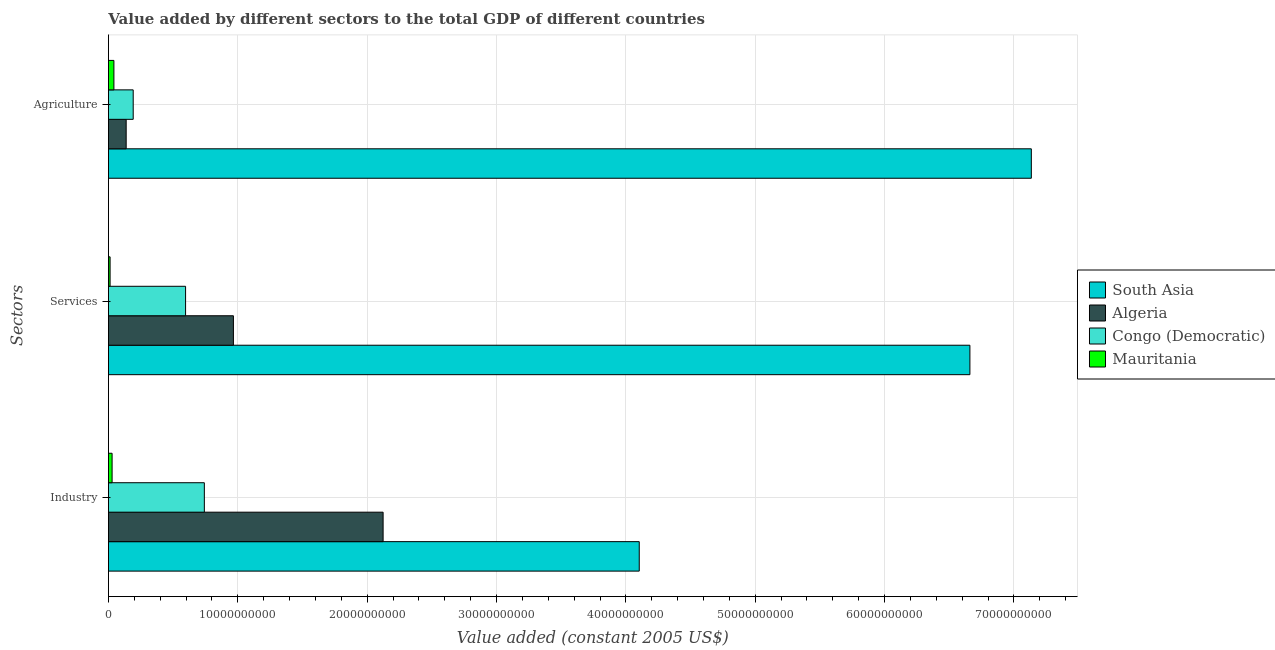How many groups of bars are there?
Make the answer very short. 3. Are the number of bars per tick equal to the number of legend labels?
Your answer should be very brief. Yes. How many bars are there on the 3rd tick from the top?
Keep it short and to the point. 4. What is the label of the 2nd group of bars from the top?
Offer a very short reply. Services. What is the value added by agricultural sector in Mauritania?
Make the answer very short. 4.24e+08. Across all countries, what is the maximum value added by services?
Your answer should be very brief. 6.66e+1. Across all countries, what is the minimum value added by industrial sector?
Offer a very short reply. 2.83e+08. In which country was the value added by agricultural sector maximum?
Your response must be concise. South Asia. In which country was the value added by industrial sector minimum?
Your response must be concise. Mauritania. What is the total value added by agricultural sector in the graph?
Give a very brief answer. 7.51e+1. What is the difference between the value added by industrial sector in Algeria and that in Congo (Democratic)?
Make the answer very short. 1.38e+1. What is the difference between the value added by industrial sector in Algeria and the value added by agricultural sector in South Asia?
Provide a succinct answer. -5.01e+1. What is the average value added by agricultural sector per country?
Provide a short and direct response. 1.88e+1. What is the difference between the value added by agricultural sector and value added by industrial sector in Mauritania?
Give a very brief answer. 1.40e+08. What is the ratio of the value added by services in Congo (Democratic) to that in Mauritania?
Your response must be concise. 46.56. Is the difference between the value added by industrial sector in Algeria and South Asia greater than the difference between the value added by services in Algeria and South Asia?
Keep it short and to the point. Yes. What is the difference between the highest and the second highest value added by industrial sector?
Offer a terse response. 1.98e+1. What is the difference between the highest and the lowest value added by agricultural sector?
Make the answer very short. 7.09e+1. Is the sum of the value added by services in Congo (Democratic) and South Asia greater than the maximum value added by agricultural sector across all countries?
Offer a very short reply. Yes. What does the 1st bar from the top in Services represents?
Offer a very short reply. Mauritania. What does the 2nd bar from the bottom in Industry represents?
Your response must be concise. Algeria. Is it the case that in every country, the sum of the value added by industrial sector and value added by services is greater than the value added by agricultural sector?
Provide a succinct answer. No. How many bars are there?
Offer a terse response. 12. How many countries are there in the graph?
Your answer should be very brief. 4. What is the difference between two consecutive major ticks on the X-axis?
Your answer should be compact. 1.00e+1. Does the graph contain grids?
Offer a terse response. Yes. How many legend labels are there?
Keep it short and to the point. 4. How are the legend labels stacked?
Offer a very short reply. Vertical. What is the title of the graph?
Your answer should be very brief. Value added by different sectors to the total GDP of different countries. Does "Guyana" appear as one of the legend labels in the graph?
Offer a very short reply. No. What is the label or title of the X-axis?
Your answer should be compact. Value added (constant 2005 US$). What is the label or title of the Y-axis?
Provide a succinct answer. Sectors. What is the Value added (constant 2005 US$) of South Asia in Industry?
Your answer should be compact. 4.10e+1. What is the Value added (constant 2005 US$) in Algeria in Industry?
Your answer should be very brief. 2.12e+1. What is the Value added (constant 2005 US$) in Congo (Democratic) in Industry?
Ensure brevity in your answer.  7.41e+09. What is the Value added (constant 2005 US$) of Mauritania in Industry?
Provide a short and direct response. 2.83e+08. What is the Value added (constant 2005 US$) of South Asia in Services?
Make the answer very short. 6.66e+1. What is the Value added (constant 2005 US$) in Algeria in Services?
Give a very brief answer. 9.66e+09. What is the Value added (constant 2005 US$) in Congo (Democratic) in Services?
Your answer should be very brief. 5.96e+09. What is the Value added (constant 2005 US$) of Mauritania in Services?
Ensure brevity in your answer.  1.28e+08. What is the Value added (constant 2005 US$) in South Asia in Agriculture?
Provide a short and direct response. 7.13e+1. What is the Value added (constant 2005 US$) of Algeria in Agriculture?
Provide a short and direct response. 1.37e+09. What is the Value added (constant 2005 US$) in Congo (Democratic) in Agriculture?
Your answer should be compact. 1.91e+09. What is the Value added (constant 2005 US$) of Mauritania in Agriculture?
Give a very brief answer. 4.24e+08. Across all Sectors, what is the maximum Value added (constant 2005 US$) of South Asia?
Provide a short and direct response. 7.13e+1. Across all Sectors, what is the maximum Value added (constant 2005 US$) of Algeria?
Provide a succinct answer. 2.12e+1. Across all Sectors, what is the maximum Value added (constant 2005 US$) in Congo (Democratic)?
Your answer should be very brief. 7.41e+09. Across all Sectors, what is the maximum Value added (constant 2005 US$) of Mauritania?
Give a very brief answer. 4.24e+08. Across all Sectors, what is the minimum Value added (constant 2005 US$) in South Asia?
Your answer should be compact. 4.10e+1. Across all Sectors, what is the minimum Value added (constant 2005 US$) in Algeria?
Give a very brief answer. 1.37e+09. Across all Sectors, what is the minimum Value added (constant 2005 US$) in Congo (Democratic)?
Your answer should be compact. 1.91e+09. Across all Sectors, what is the minimum Value added (constant 2005 US$) of Mauritania?
Provide a succinct answer. 1.28e+08. What is the total Value added (constant 2005 US$) of South Asia in the graph?
Ensure brevity in your answer.  1.79e+11. What is the total Value added (constant 2005 US$) of Algeria in the graph?
Give a very brief answer. 3.23e+1. What is the total Value added (constant 2005 US$) of Congo (Democratic) in the graph?
Provide a succinct answer. 1.53e+1. What is the total Value added (constant 2005 US$) of Mauritania in the graph?
Make the answer very short. 8.35e+08. What is the difference between the Value added (constant 2005 US$) in South Asia in Industry and that in Services?
Offer a very short reply. -2.56e+1. What is the difference between the Value added (constant 2005 US$) of Algeria in Industry and that in Services?
Your response must be concise. 1.16e+1. What is the difference between the Value added (constant 2005 US$) of Congo (Democratic) in Industry and that in Services?
Give a very brief answer. 1.45e+09. What is the difference between the Value added (constant 2005 US$) in Mauritania in Industry and that in Services?
Make the answer very short. 1.55e+08. What is the difference between the Value added (constant 2005 US$) of South Asia in Industry and that in Agriculture?
Keep it short and to the point. -3.03e+1. What is the difference between the Value added (constant 2005 US$) of Algeria in Industry and that in Agriculture?
Offer a terse response. 1.99e+1. What is the difference between the Value added (constant 2005 US$) in Congo (Democratic) in Industry and that in Agriculture?
Ensure brevity in your answer.  5.50e+09. What is the difference between the Value added (constant 2005 US$) in Mauritania in Industry and that in Agriculture?
Provide a short and direct response. -1.40e+08. What is the difference between the Value added (constant 2005 US$) in South Asia in Services and that in Agriculture?
Provide a short and direct response. -4.75e+09. What is the difference between the Value added (constant 2005 US$) of Algeria in Services and that in Agriculture?
Your answer should be compact. 8.29e+09. What is the difference between the Value added (constant 2005 US$) in Congo (Democratic) in Services and that in Agriculture?
Provide a succinct answer. 4.05e+09. What is the difference between the Value added (constant 2005 US$) of Mauritania in Services and that in Agriculture?
Provide a succinct answer. -2.95e+08. What is the difference between the Value added (constant 2005 US$) of South Asia in Industry and the Value added (constant 2005 US$) of Algeria in Services?
Keep it short and to the point. 3.14e+1. What is the difference between the Value added (constant 2005 US$) of South Asia in Industry and the Value added (constant 2005 US$) of Congo (Democratic) in Services?
Ensure brevity in your answer.  3.51e+1. What is the difference between the Value added (constant 2005 US$) of South Asia in Industry and the Value added (constant 2005 US$) of Mauritania in Services?
Ensure brevity in your answer.  4.09e+1. What is the difference between the Value added (constant 2005 US$) in Algeria in Industry and the Value added (constant 2005 US$) in Congo (Democratic) in Services?
Your response must be concise. 1.53e+1. What is the difference between the Value added (constant 2005 US$) in Algeria in Industry and the Value added (constant 2005 US$) in Mauritania in Services?
Provide a succinct answer. 2.11e+1. What is the difference between the Value added (constant 2005 US$) in Congo (Democratic) in Industry and the Value added (constant 2005 US$) in Mauritania in Services?
Make the answer very short. 7.29e+09. What is the difference between the Value added (constant 2005 US$) in South Asia in Industry and the Value added (constant 2005 US$) in Algeria in Agriculture?
Provide a succinct answer. 3.97e+1. What is the difference between the Value added (constant 2005 US$) of South Asia in Industry and the Value added (constant 2005 US$) of Congo (Democratic) in Agriculture?
Ensure brevity in your answer.  3.91e+1. What is the difference between the Value added (constant 2005 US$) of South Asia in Industry and the Value added (constant 2005 US$) of Mauritania in Agriculture?
Your response must be concise. 4.06e+1. What is the difference between the Value added (constant 2005 US$) of Algeria in Industry and the Value added (constant 2005 US$) of Congo (Democratic) in Agriculture?
Provide a short and direct response. 1.93e+1. What is the difference between the Value added (constant 2005 US$) in Algeria in Industry and the Value added (constant 2005 US$) in Mauritania in Agriculture?
Your response must be concise. 2.08e+1. What is the difference between the Value added (constant 2005 US$) of Congo (Democratic) in Industry and the Value added (constant 2005 US$) of Mauritania in Agriculture?
Provide a short and direct response. 6.99e+09. What is the difference between the Value added (constant 2005 US$) in South Asia in Services and the Value added (constant 2005 US$) in Algeria in Agriculture?
Your answer should be very brief. 6.52e+1. What is the difference between the Value added (constant 2005 US$) in South Asia in Services and the Value added (constant 2005 US$) in Congo (Democratic) in Agriculture?
Provide a short and direct response. 6.47e+1. What is the difference between the Value added (constant 2005 US$) in South Asia in Services and the Value added (constant 2005 US$) in Mauritania in Agriculture?
Give a very brief answer. 6.62e+1. What is the difference between the Value added (constant 2005 US$) of Algeria in Services and the Value added (constant 2005 US$) of Congo (Democratic) in Agriculture?
Your answer should be very brief. 7.75e+09. What is the difference between the Value added (constant 2005 US$) of Algeria in Services and the Value added (constant 2005 US$) of Mauritania in Agriculture?
Your answer should be very brief. 9.24e+09. What is the difference between the Value added (constant 2005 US$) in Congo (Democratic) in Services and the Value added (constant 2005 US$) in Mauritania in Agriculture?
Offer a terse response. 5.54e+09. What is the average Value added (constant 2005 US$) of South Asia per Sectors?
Your response must be concise. 5.97e+1. What is the average Value added (constant 2005 US$) of Algeria per Sectors?
Provide a succinct answer. 1.08e+1. What is the average Value added (constant 2005 US$) in Congo (Democratic) per Sectors?
Provide a succinct answer. 5.10e+09. What is the average Value added (constant 2005 US$) in Mauritania per Sectors?
Keep it short and to the point. 2.78e+08. What is the difference between the Value added (constant 2005 US$) of South Asia and Value added (constant 2005 US$) of Algeria in Industry?
Keep it short and to the point. 1.98e+1. What is the difference between the Value added (constant 2005 US$) in South Asia and Value added (constant 2005 US$) in Congo (Democratic) in Industry?
Keep it short and to the point. 3.36e+1. What is the difference between the Value added (constant 2005 US$) in South Asia and Value added (constant 2005 US$) in Mauritania in Industry?
Offer a very short reply. 4.08e+1. What is the difference between the Value added (constant 2005 US$) in Algeria and Value added (constant 2005 US$) in Congo (Democratic) in Industry?
Offer a very short reply. 1.38e+1. What is the difference between the Value added (constant 2005 US$) in Algeria and Value added (constant 2005 US$) in Mauritania in Industry?
Ensure brevity in your answer.  2.09e+1. What is the difference between the Value added (constant 2005 US$) of Congo (Democratic) and Value added (constant 2005 US$) of Mauritania in Industry?
Offer a very short reply. 7.13e+09. What is the difference between the Value added (constant 2005 US$) of South Asia and Value added (constant 2005 US$) of Algeria in Services?
Your answer should be very brief. 5.69e+1. What is the difference between the Value added (constant 2005 US$) in South Asia and Value added (constant 2005 US$) in Congo (Democratic) in Services?
Your response must be concise. 6.06e+1. What is the difference between the Value added (constant 2005 US$) in South Asia and Value added (constant 2005 US$) in Mauritania in Services?
Your answer should be compact. 6.65e+1. What is the difference between the Value added (constant 2005 US$) of Algeria and Value added (constant 2005 US$) of Congo (Democratic) in Services?
Make the answer very short. 3.70e+09. What is the difference between the Value added (constant 2005 US$) of Algeria and Value added (constant 2005 US$) of Mauritania in Services?
Offer a terse response. 9.53e+09. What is the difference between the Value added (constant 2005 US$) of Congo (Democratic) and Value added (constant 2005 US$) of Mauritania in Services?
Offer a terse response. 5.84e+09. What is the difference between the Value added (constant 2005 US$) of South Asia and Value added (constant 2005 US$) of Algeria in Agriculture?
Your answer should be compact. 7.00e+1. What is the difference between the Value added (constant 2005 US$) in South Asia and Value added (constant 2005 US$) in Congo (Democratic) in Agriculture?
Provide a short and direct response. 6.94e+1. What is the difference between the Value added (constant 2005 US$) in South Asia and Value added (constant 2005 US$) in Mauritania in Agriculture?
Your answer should be very brief. 7.09e+1. What is the difference between the Value added (constant 2005 US$) of Algeria and Value added (constant 2005 US$) of Congo (Democratic) in Agriculture?
Make the answer very short. -5.43e+08. What is the difference between the Value added (constant 2005 US$) of Algeria and Value added (constant 2005 US$) of Mauritania in Agriculture?
Offer a very short reply. 9.48e+08. What is the difference between the Value added (constant 2005 US$) of Congo (Democratic) and Value added (constant 2005 US$) of Mauritania in Agriculture?
Your answer should be very brief. 1.49e+09. What is the ratio of the Value added (constant 2005 US$) in South Asia in Industry to that in Services?
Your answer should be very brief. 0.62. What is the ratio of the Value added (constant 2005 US$) in Algeria in Industry to that in Services?
Make the answer very short. 2.2. What is the ratio of the Value added (constant 2005 US$) of Congo (Democratic) in Industry to that in Services?
Your answer should be very brief. 1.24. What is the ratio of the Value added (constant 2005 US$) in Mauritania in Industry to that in Services?
Ensure brevity in your answer.  2.21. What is the ratio of the Value added (constant 2005 US$) in South Asia in Industry to that in Agriculture?
Ensure brevity in your answer.  0.58. What is the ratio of the Value added (constant 2005 US$) in Algeria in Industry to that in Agriculture?
Make the answer very short. 15.48. What is the ratio of the Value added (constant 2005 US$) in Congo (Democratic) in Industry to that in Agriculture?
Provide a succinct answer. 3.87. What is the ratio of the Value added (constant 2005 US$) in Mauritania in Industry to that in Agriculture?
Give a very brief answer. 0.67. What is the ratio of the Value added (constant 2005 US$) of South Asia in Services to that in Agriculture?
Provide a short and direct response. 0.93. What is the ratio of the Value added (constant 2005 US$) of Algeria in Services to that in Agriculture?
Ensure brevity in your answer.  7.04. What is the ratio of the Value added (constant 2005 US$) of Congo (Democratic) in Services to that in Agriculture?
Ensure brevity in your answer.  3.12. What is the ratio of the Value added (constant 2005 US$) in Mauritania in Services to that in Agriculture?
Provide a short and direct response. 0.3. What is the difference between the highest and the second highest Value added (constant 2005 US$) in South Asia?
Make the answer very short. 4.75e+09. What is the difference between the highest and the second highest Value added (constant 2005 US$) in Algeria?
Your response must be concise. 1.16e+1. What is the difference between the highest and the second highest Value added (constant 2005 US$) of Congo (Democratic)?
Ensure brevity in your answer.  1.45e+09. What is the difference between the highest and the second highest Value added (constant 2005 US$) of Mauritania?
Provide a short and direct response. 1.40e+08. What is the difference between the highest and the lowest Value added (constant 2005 US$) of South Asia?
Your answer should be compact. 3.03e+1. What is the difference between the highest and the lowest Value added (constant 2005 US$) in Algeria?
Your answer should be compact. 1.99e+1. What is the difference between the highest and the lowest Value added (constant 2005 US$) of Congo (Democratic)?
Give a very brief answer. 5.50e+09. What is the difference between the highest and the lowest Value added (constant 2005 US$) of Mauritania?
Ensure brevity in your answer.  2.95e+08. 